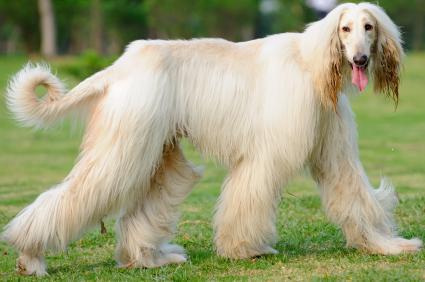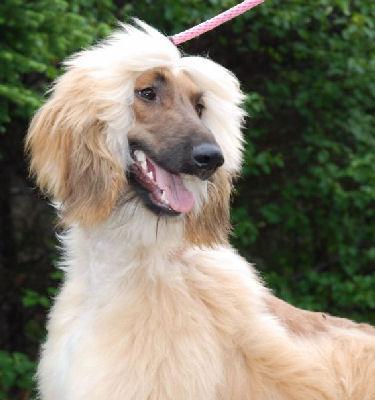The first image is the image on the left, the second image is the image on the right. For the images shown, is this caption "The dog in the image on the left is taking strides as it walks outside." true? Answer yes or no. Yes. 